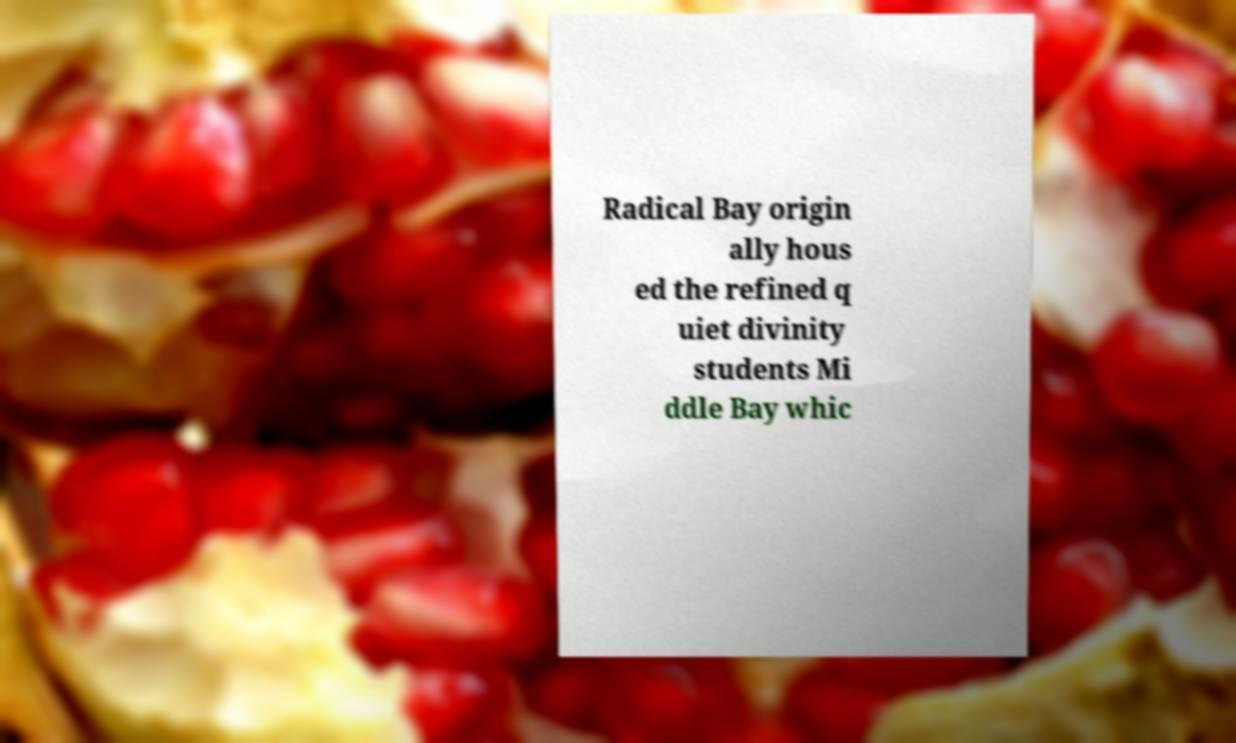What messages or text are displayed in this image? I need them in a readable, typed format. Radical Bay origin ally hous ed the refined q uiet divinity students Mi ddle Bay whic 